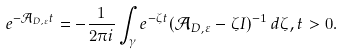<formula> <loc_0><loc_0><loc_500><loc_500>e ^ { - \mathcal { A } _ { D , \varepsilon } t } = - \frac { 1 } { 2 \pi i } \int _ { \gamma } e ^ { - \zeta t } ( \mathcal { A } _ { D , \varepsilon } - \zeta I ) ^ { - 1 } \, d \zeta , t > 0 .</formula> 